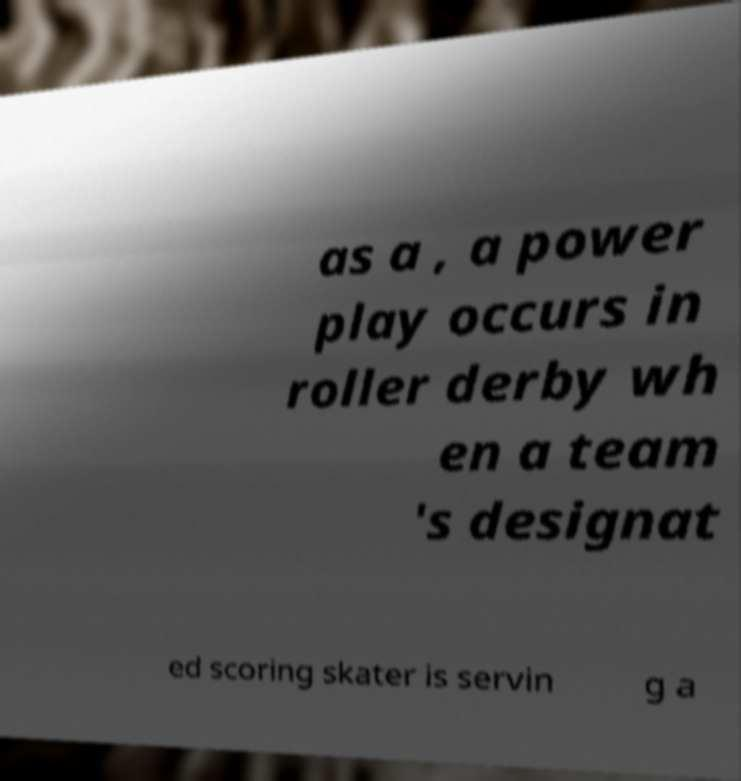For documentation purposes, I need the text within this image transcribed. Could you provide that? as a , a power play occurs in roller derby wh en a team 's designat ed scoring skater is servin g a 